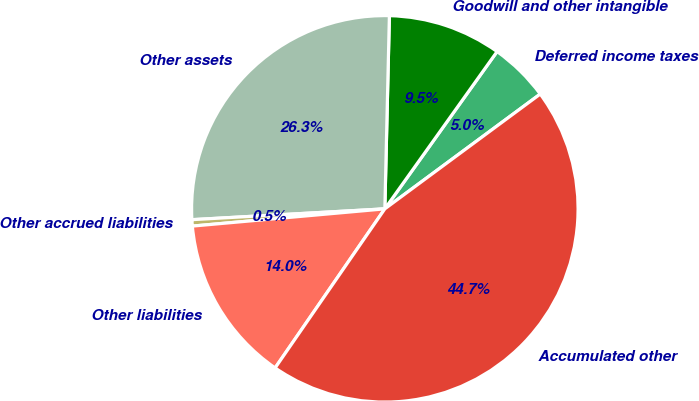Convert chart to OTSL. <chart><loc_0><loc_0><loc_500><loc_500><pie_chart><fcel>Deferred income taxes<fcel>Goodwill and other intangible<fcel>Other assets<fcel>Other accrued liabilities<fcel>Other liabilities<fcel>Accumulated other<nl><fcel>5.01%<fcel>9.49%<fcel>26.27%<fcel>0.53%<fcel>13.97%<fcel>44.74%<nl></chart> 